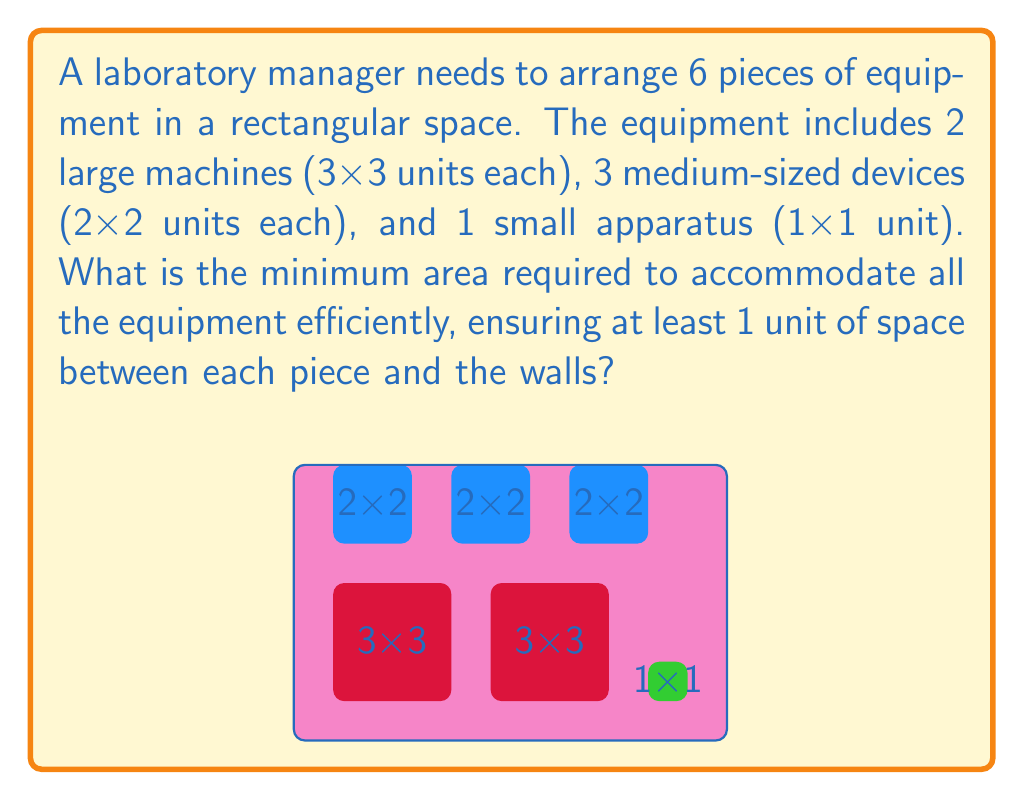Solve this math problem. To solve this problem, we need to follow these steps:

1) First, calculate the total area occupied by the equipment:
   - 2 large machines: $2 \times (3 \times 3) = 18$ square units
   - 3 medium devices: $3 \times (2 \times 2) = 12$ square units
   - 1 small apparatus: $1 \times (1 \times 1) = 1$ square unit
   Total equipment area: $18 + 12 + 1 = 31$ square units

2) Now, we need to arrange these in a rectangular space, keeping in mind the 1-unit spacing requirement.

3) The most efficient arrangement would be to place the large machines side by side, with the medium devices above them, and the small apparatus in a corner.

4) Calculating the dimensions:
   Width: $3 + 1 + 3 + 1 + 3 = 11$ units (two large machines with spacing and wall space)
   Height: $3 + 1 + 2 + 1 = 7$ units (height of large machine + space + medium device + wall space)

5) Therefore, the minimum rectangular area required is:
   $A = 11 \times 7 = 77$ square units

This arrangement efficiently uses the space while maintaining the required spacing between equipment and walls.
Answer: 77 square units 